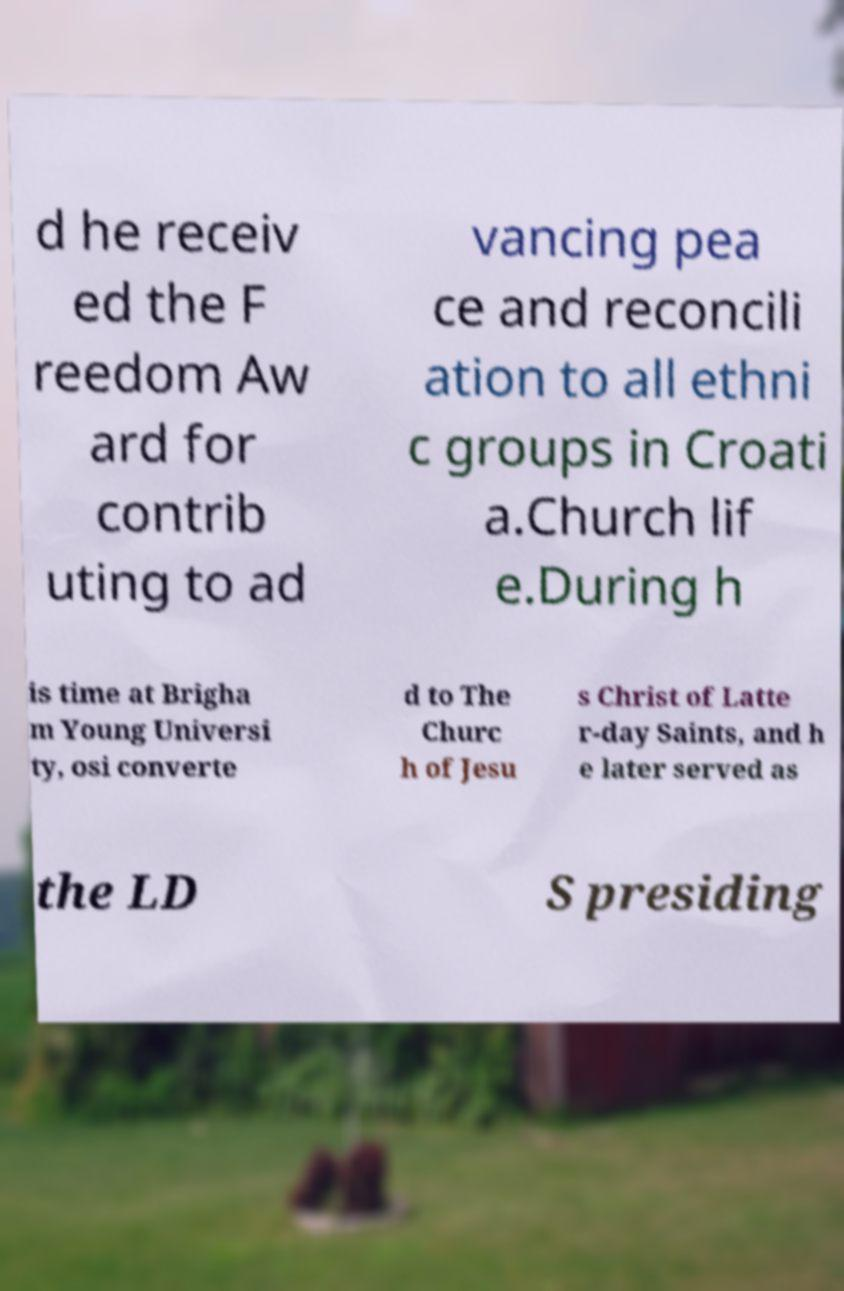What messages or text are displayed in this image? I need them in a readable, typed format. d he receiv ed the F reedom Aw ard for contrib uting to ad vancing pea ce and reconcili ation to all ethni c groups in Croati a.Church lif e.During h is time at Brigha m Young Universi ty, osi converte d to The Churc h of Jesu s Christ of Latte r-day Saints, and h e later served as the LD S presiding 